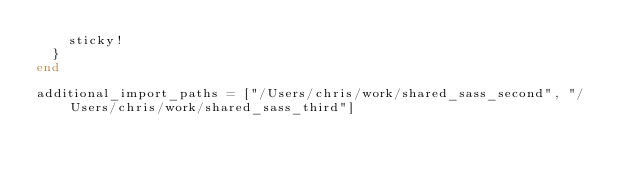Convert code to text. <code><loc_0><loc_0><loc_500><loc_500><_Ruby_>    sticky!
  }
end

additional_import_paths = ["/Users/chris/work/shared_sass_second", "/Users/chris/work/shared_sass_third"]
</code> 